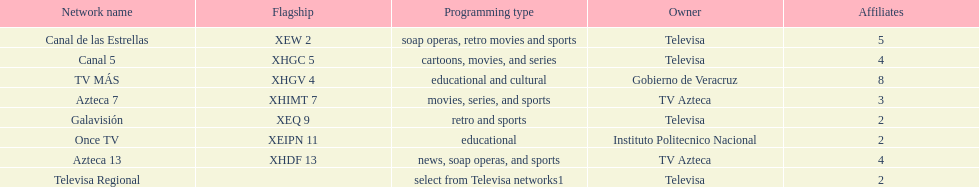Whose networks are the most numerous among owners? Televisa. 